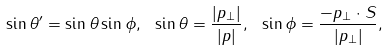Convert formula to latex. <formula><loc_0><loc_0><loc_500><loc_500>\sin \theta ^ { \prime } = \sin \theta \sin \phi , \ \sin \theta = \frac { | { p } _ { \perp } | } { | { p } | } , \ \sin \phi = \frac { - p _ { \perp } \cdot S } { | { p } _ { \perp } | } ,</formula> 